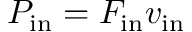<formula> <loc_0><loc_0><loc_500><loc_500>P _ { i n } = F _ { i n } v _ { i n }</formula> 